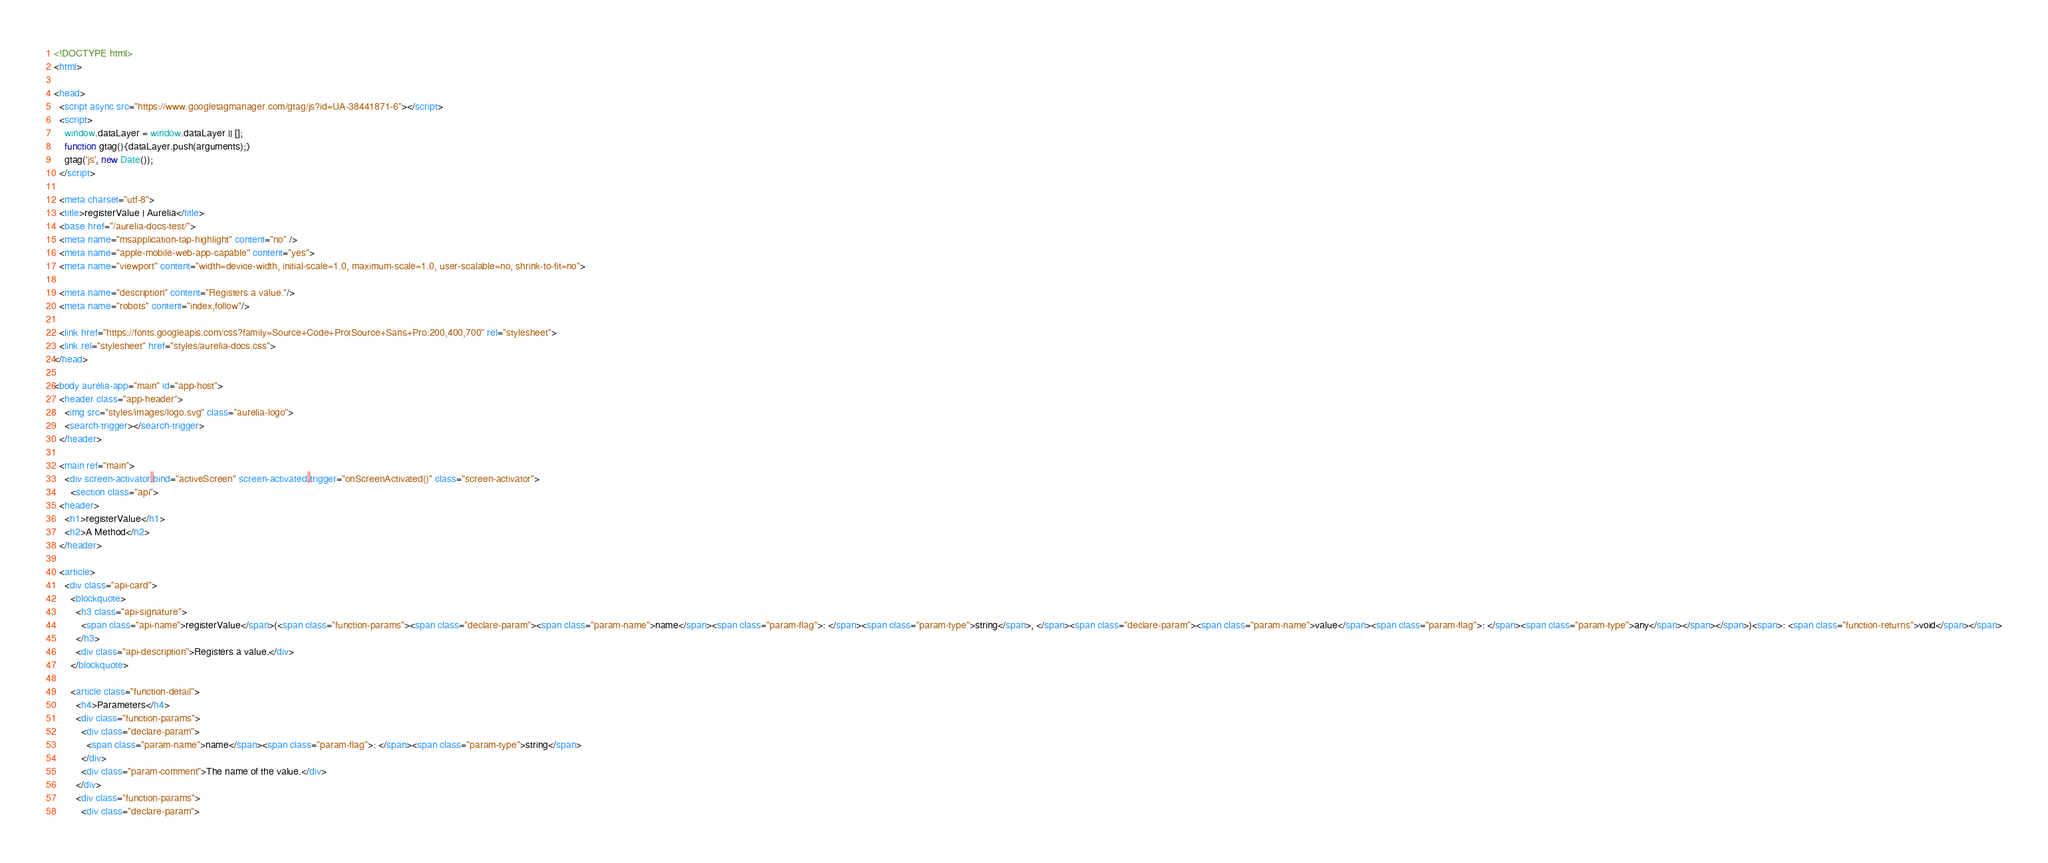Convert code to text. <code><loc_0><loc_0><loc_500><loc_500><_HTML_><!DOCTYPE html>
<html>

<head>
  <script async src="https://www.googletagmanager.com/gtag/js?id=UA-38441871-6"></script>
  <script>
    window.dataLayer = window.dataLayer || [];
    function gtag(){dataLayer.push(arguments);}
    gtag('js', new Date());
  </script>

  <meta charset="utf-8">
  <title>registerValue | Aurelia</title>
  <base href="/aurelia-docs-test/">
  <meta name="msapplication-tap-highlight" content="no" />
  <meta name="apple-mobile-web-app-capable" content="yes">
  <meta name="viewport" content="width=device-width, initial-scale=1.0, maximum-scale=1.0, user-scalable=no, shrink-to-fit=no">
  
  <meta name="description" content="Registers a value."/>
  <meta name="robots" content="index,follow"/>
  
  <link href="https://fonts.googleapis.com/css?family=Source+Code+Pro|Source+Sans+Pro:200,400,700" rel="stylesheet">
  <link rel="stylesheet" href="styles/aurelia-docs.css">
</head>

<body aurelia-app="main" id="app-host">
  <header class="app-header"> 
    <img src="styles/images/logo.svg" class="aurelia-logo">
    <search-trigger></search-trigger>
  </header>

  <main ref="main">
    <div screen-activator.bind="activeScreen" screen-activated.trigger="onScreenActivated()" class="screen-activator">
      <section class="api">
  <header>
    <h1>registerValue</h1>
    <h2>A Method</h2>
  </header>

  <article>
    <div class="api-card">
      <blockquote>
        <h3 class="api-signature">
          <span class="api-name">registerValue</span>(<span class="function-params"><span class="declare-param"><span class="param-name">name</span><span class="param-flag">: </span><span class="param-type">string</span>, </span><span class="declare-param"><span class="param-name">value</span><span class="param-flag">: </span><span class="param-type">any</span></span></span>)<span>: <span class="function-returns">void</span></span>
        </h3>
        <div class="api-description">Registers a value.</div>
      </blockquote>
    
      <article class="function-detail">
        <h4>Parameters</h4>
        <div class="function-params">
          <div class="declare-param">
            <span class="param-name">name</span><span class="param-flag">: </span><span class="param-type">string</span>
          </div>
          <div class="param-comment">The name of the value.</div>
        </div>
        <div class="function-params">
          <div class="declare-param"></code> 